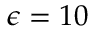Convert formula to latex. <formula><loc_0><loc_0><loc_500><loc_500>\epsilon = 1 0</formula> 